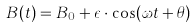Convert formula to latex. <formula><loc_0><loc_0><loc_500><loc_500>B ( t ) = B _ { 0 } + \epsilon \cdot \cos ( \omega t + \theta )</formula> 